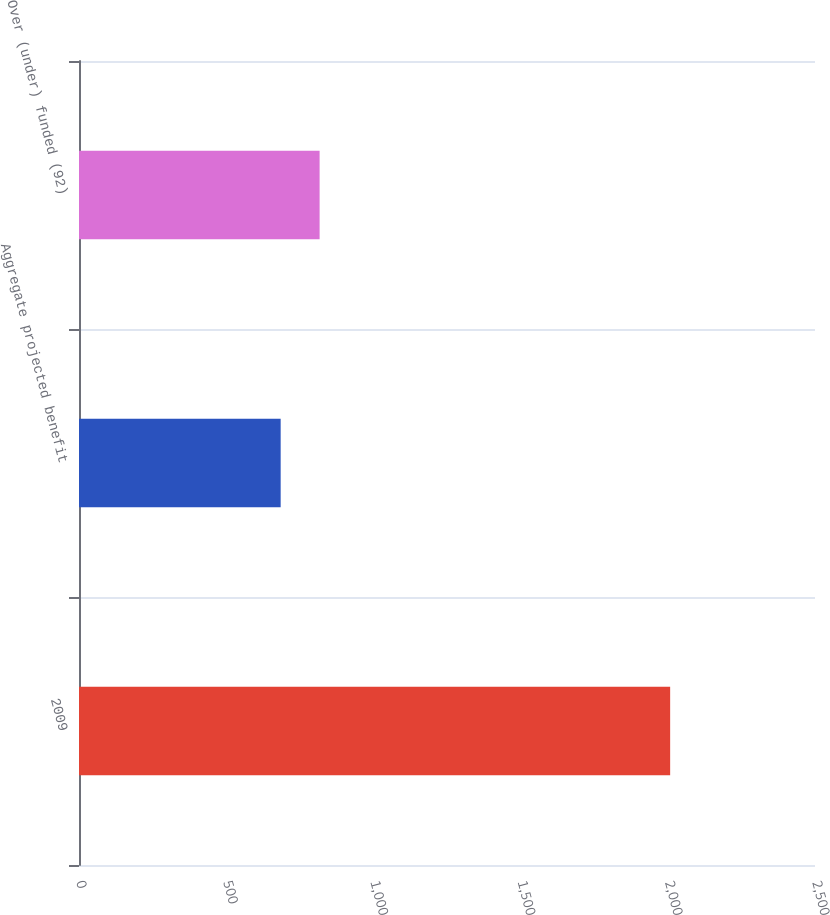Convert chart to OTSL. <chart><loc_0><loc_0><loc_500><loc_500><bar_chart><fcel>2009<fcel>Aggregate projected benefit<fcel>Over (under) funded (92)<nl><fcel>2008<fcel>685<fcel>817.3<nl></chart> 